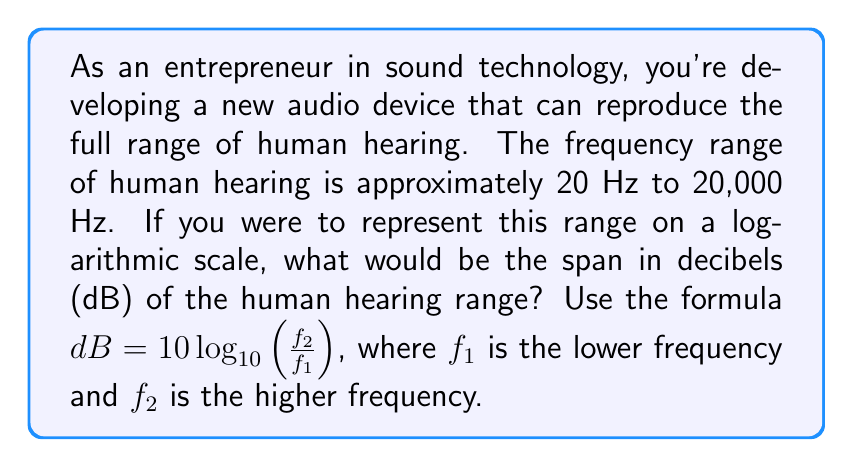Could you help me with this problem? To solve this problem, we need to use the given formula and the known frequency range of human hearing. Let's break it down step-by-step:

1. We know that:
   $f_1 = 20$ Hz (lower frequency)
   $f_2 = 20,000$ Hz (higher frequency)

2. Let's plug these values into the formula:

   $$dB = 10 \log_{10}(\frac{f_2}{f_1})$$
   
   $$dB = 10 \log_{10}(\frac{20,000}{20})$$

3. Simplify the fraction inside the logarithm:

   $$dB = 10 \log_{10}(1000)$$

4. Now, we can use the logarithm property: $\log_a(x^n) = n \log_a(x)$
   
   1000 can be written as $10^3$, so:

   $$dB = 10 \log_{10}(10^3)$$
   $$dB = 10 \cdot 3 \log_{10}(10)$$

5. We know that $\log_{10}(10) = 1$, so:

   $$dB = 10 \cdot 3 \cdot 1$$
   $$dB = 30$$

Therefore, the span of the human hearing range on a logarithmic scale is 30 dB.
Answer: 30 dB 